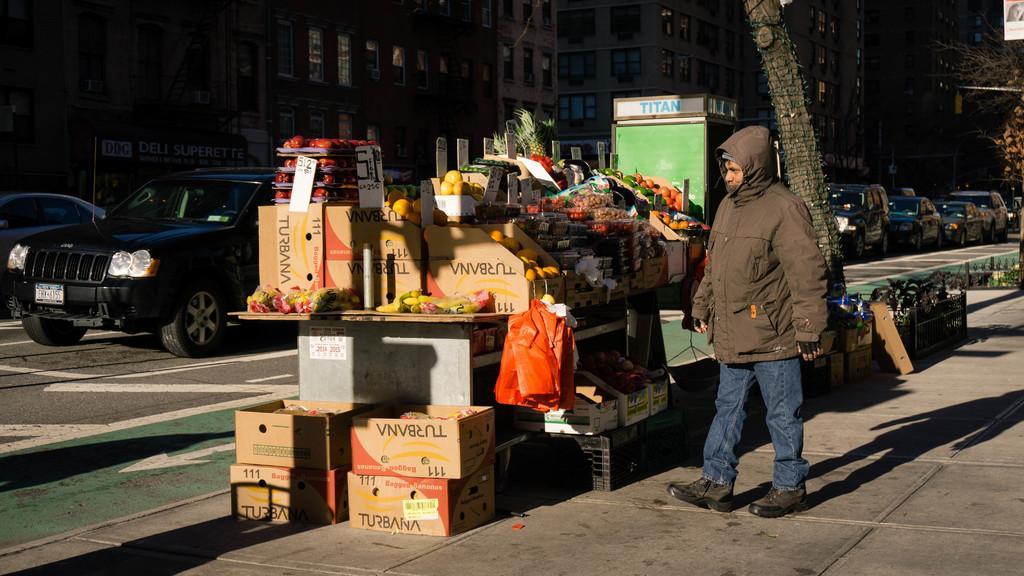How would you summarize this image in a sentence or two? On the right side there are cars in the middle a person is walking he wear a coat. 